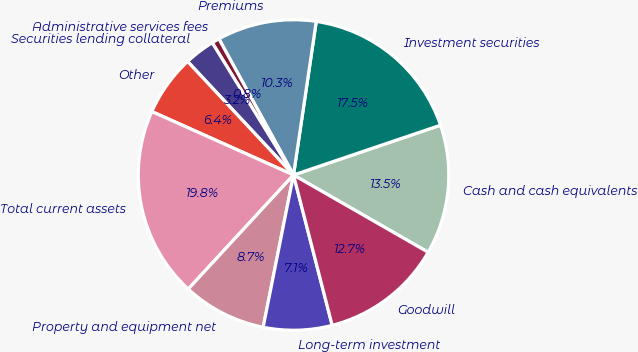<chart> <loc_0><loc_0><loc_500><loc_500><pie_chart><fcel>Cash and cash equivalents<fcel>Investment securities<fcel>Premiums<fcel>Administrative services fees<fcel>Securities lending collateral<fcel>Other<fcel>Total current assets<fcel>Property and equipment net<fcel>Long-term investment<fcel>Goodwill<nl><fcel>13.49%<fcel>17.46%<fcel>10.32%<fcel>0.79%<fcel>3.18%<fcel>6.35%<fcel>19.84%<fcel>8.73%<fcel>7.14%<fcel>12.7%<nl></chart> 